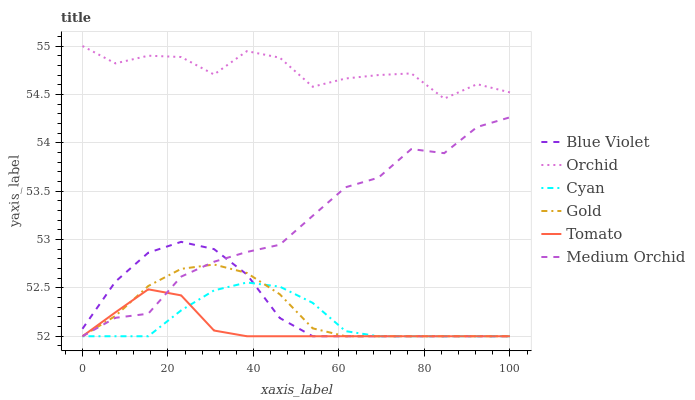Does Tomato have the minimum area under the curve?
Answer yes or no. Yes. Does Orchid have the maximum area under the curve?
Answer yes or no. Yes. Does Gold have the minimum area under the curve?
Answer yes or no. No. Does Gold have the maximum area under the curve?
Answer yes or no. No. Is Tomato the smoothest?
Answer yes or no. Yes. Is Orchid the roughest?
Answer yes or no. Yes. Is Gold the smoothest?
Answer yes or no. No. Is Gold the roughest?
Answer yes or no. No. Does Orchid have the lowest value?
Answer yes or no. No. Does Orchid have the highest value?
Answer yes or no. Yes. Does Gold have the highest value?
Answer yes or no. No. Is Medium Orchid less than Orchid?
Answer yes or no. Yes. Is Orchid greater than Medium Orchid?
Answer yes or no. Yes. Does Gold intersect Blue Violet?
Answer yes or no. Yes. Is Gold less than Blue Violet?
Answer yes or no. No. Is Gold greater than Blue Violet?
Answer yes or no. No. Does Medium Orchid intersect Orchid?
Answer yes or no. No. 